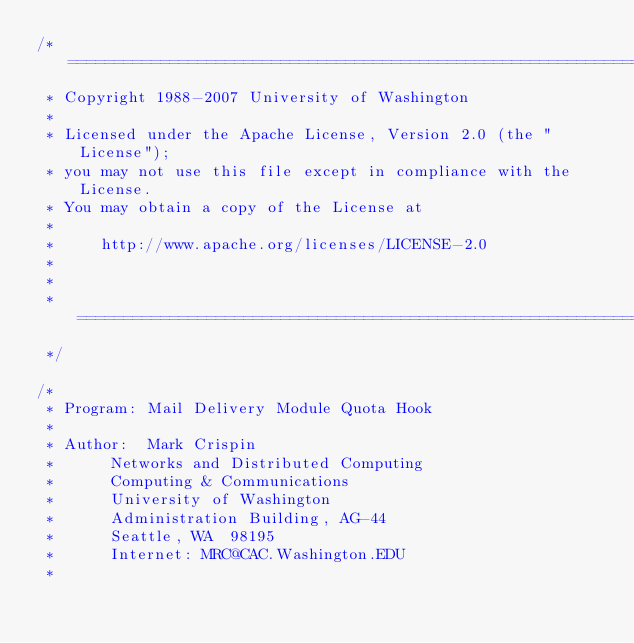<code> <loc_0><loc_0><loc_500><loc_500><_C_>/* ========================================================================
 * Copyright 1988-2007 University of Washington
 *
 * Licensed under the Apache License, Version 2.0 (the "License");
 * you may not use this file except in compliance with the License.
 * You may obtain a copy of the License at
 *
 *     http://www.apache.org/licenses/LICENSE-2.0
 *
 * 
 * ========================================================================
 */

/*
 * Program:	Mail Delivery Module Quota Hook
 *
 * Author:	Mark Crispin
 *		Networks and Distributed Computing
 *		Computing & Communications
 *		University of Washington
 *		Administration Building, AG-44
 *		Seattle, WA  98195
 *		Internet: MRC@CAC.Washington.EDU
 *</code> 